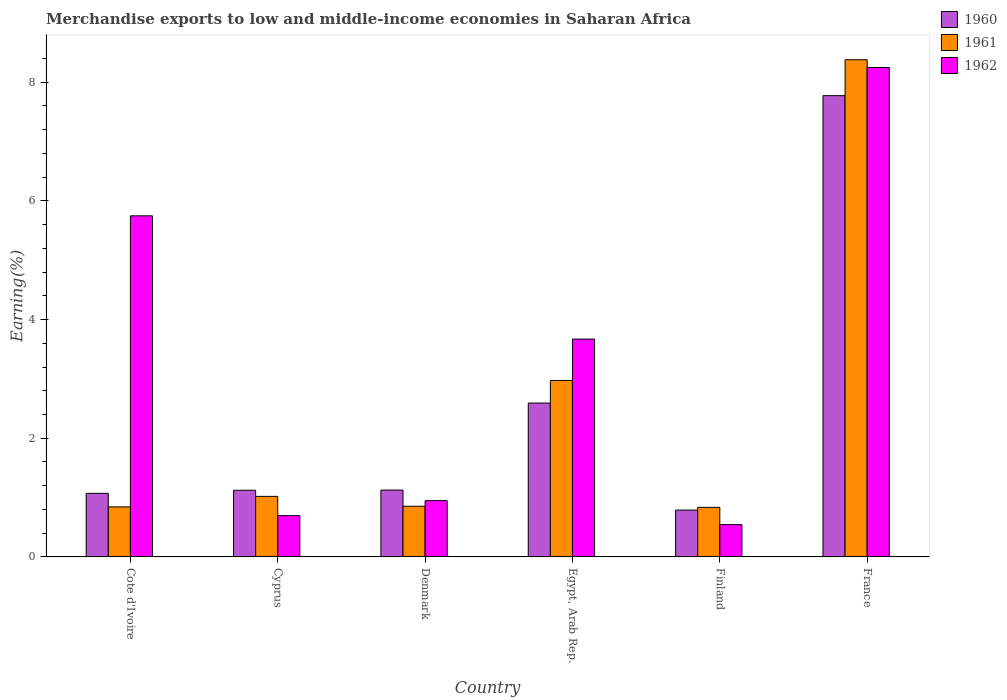Are the number of bars on each tick of the X-axis equal?
Your response must be concise. Yes. How many bars are there on the 3rd tick from the left?
Ensure brevity in your answer.  3. How many bars are there on the 4th tick from the right?
Make the answer very short. 3. What is the label of the 2nd group of bars from the left?
Give a very brief answer. Cyprus. What is the percentage of amount earned from merchandise exports in 1960 in France?
Your answer should be very brief. 7.77. Across all countries, what is the maximum percentage of amount earned from merchandise exports in 1962?
Provide a short and direct response. 8.25. Across all countries, what is the minimum percentage of amount earned from merchandise exports in 1961?
Keep it short and to the point. 0.84. In which country was the percentage of amount earned from merchandise exports in 1962 maximum?
Provide a short and direct response. France. In which country was the percentage of amount earned from merchandise exports in 1960 minimum?
Offer a terse response. Finland. What is the total percentage of amount earned from merchandise exports in 1962 in the graph?
Provide a succinct answer. 19.86. What is the difference between the percentage of amount earned from merchandise exports in 1962 in Denmark and that in France?
Your response must be concise. -7.3. What is the difference between the percentage of amount earned from merchandise exports in 1960 in Denmark and the percentage of amount earned from merchandise exports in 1961 in Cote d'Ivoire?
Provide a short and direct response. 0.28. What is the average percentage of amount earned from merchandise exports in 1960 per country?
Offer a very short reply. 2.41. What is the difference between the percentage of amount earned from merchandise exports of/in 1960 and percentage of amount earned from merchandise exports of/in 1961 in Egypt, Arab Rep.?
Your answer should be very brief. -0.38. What is the ratio of the percentage of amount earned from merchandise exports in 1960 in Egypt, Arab Rep. to that in France?
Ensure brevity in your answer.  0.33. Is the percentage of amount earned from merchandise exports in 1960 in Egypt, Arab Rep. less than that in Finland?
Provide a short and direct response. No. Is the difference between the percentage of amount earned from merchandise exports in 1960 in Cote d'Ivoire and Denmark greater than the difference between the percentage of amount earned from merchandise exports in 1961 in Cote d'Ivoire and Denmark?
Provide a succinct answer. No. What is the difference between the highest and the second highest percentage of amount earned from merchandise exports in 1961?
Ensure brevity in your answer.  7.36. What is the difference between the highest and the lowest percentage of amount earned from merchandise exports in 1961?
Make the answer very short. 7.54. Is the sum of the percentage of amount earned from merchandise exports in 1960 in Cote d'Ivoire and Cyprus greater than the maximum percentage of amount earned from merchandise exports in 1961 across all countries?
Offer a very short reply. No. What does the 1st bar from the right in Finland represents?
Your answer should be compact. 1962. How many countries are there in the graph?
Provide a succinct answer. 6. What is the difference between two consecutive major ticks on the Y-axis?
Keep it short and to the point. 2. Does the graph contain any zero values?
Keep it short and to the point. No. Does the graph contain grids?
Make the answer very short. No. Where does the legend appear in the graph?
Keep it short and to the point. Top right. How many legend labels are there?
Your answer should be compact. 3. How are the legend labels stacked?
Ensure brevity in your answer.  Vertical. What is the title of the graph?
Provide a succinct answer. Merchandise exports to low and middle-income economies in Saharan Africa. Does "1987" appear as one of the legend labels in the graph?
Keep it short and to the point. No. What is the label or title of the X-axis?
Your answer should be compact. Country. What is the label or title of the Y-axis?
Offer a very short reply. Earning(%). What is the Earning(%) of 1960 in Cote d'Ivoire?
Provide a succinct answer. 1.07. What is the Earning(%) in 1961 in Cote d'Ivoire?
Keep it short and to the point. 0.84. What is the Earning(%) in 1962 in Cote d'Ivoire?
Your response must be concise. 5.75. What is the Earning(%) in 1960 in Cyprus?
Offer a terse response. 1.12. What is the Earning(%) in 1961 in Cyprus?
Keep it short and to the point. 1.02. What is the Earning(%) of 1962 in Cyprus?
Your response must be concise. 0.7. What is the Earning(%) in 1960 in Denmark?
Keep it short and to the point. 1.13. What is the Earning(%) of 1961 in Denmark?
Give a very brief answer. 0.85. What is the Earning(%) in 1962 in Denmark?
Ensure brevity in your answer.  0.95. What is the Earning(%) of 1960 in Egypt, Arab Rep.?
Offer a very short reply. 2.59. What is the Earning(%) of 1961 in Egypt, Arab Rep.?
Your answer should be very brief. 2.97. What is the Earning(%) in 1962 in Egypt, Arab Rep.?
Make the answer very short. 3.67. What is the Earning(%) of 1960 in Finland?
Offer a very short reply. 0.79. What is the Earning(%) of 1961 in Finland?
Your response must be concise. 0.84. What is the Earning(%) in 1962 in Finland?
Make the answer very short. 0.54. What is the Earning(%) in 1960 in France?
Your response must be concise. 7.77. What is the Earning(%) in 1961 in France?
Provide a succinct answer. 8.38. What is the Earning(%) of 1962 in France?
Provide a short and direct response. 8.25. Across all countries, what is the maximum Earning(%) of 1960?
Your response must be concise. 7.77. Across all countries, what is the maximum Earning(%) in 1961?
Provide a short and direct response. 8.38. Across all countries, what is the maximum Earning(%) in 1962?
Offer a terse response. 8.25. Across all countries, what is the minimum Earning(%) in 1960?
Offer a very short reply. 0.79. Across all countries, what is the minimum Earning(%) in 1961?
Provide a succinct answer. 0.84. Across all countries, what is the minimum Earning(%) in 1962?
Provide a succinct answer. 0.54. What is the total Earning(%) of 1960 in the graph?
Give a very brief answer. 14.48. What is the total Earning(%) in 1961 in the graph?
Your answer should be compact. 14.91. What is the total Earning(%) of 1962 in the graph?
Give a very brief answer. 19.86. What is the difference between the Earning(%) of 1960 in Cote d'Ivoire and that in Cyprus?
Offer a very short reply. -0.05. What is the difference between the Earning(%) in 1961 in Cote d'Ivoire and that in Cyprus?
Keep it short and to the point. -0.18. What is the difference between the Earning(%) of 1962 in Cote d'Ivoire and that in Cyprus?
Offer a very short reply. 5.05. What is the difference between the Earning(%) in 1960 in Cote d'Ivoire and that in Denmark?
Offer a terse response. -0.06. What is the difference between the Earning(%) of 1961 in Cote d'Ivoire and that in Denmark?
Provide a short and direct response. -0.01. What is the difference between the Earning(%) in 1962 in Cote d'Ivoire and that in Denmark?
Offer a very short reply. 4.8. What is the difference between the Earning(%) of 1960 in Cote d'Ivoire and that in Egypt, Arab Rep.?
Make the answer very short. -1.52. What is the difference between the Earning(%) of 1961 in Cote d'Ivoire and that in Egypt, Arab Rep.?
Your answer should be compact. -2.13. What is the difference between the Earning(%) in 1962 in Cote d'Ivoire and that in Egypt, Arab Rep.?
Ensure brevity in your answer.  2.08. What is the difference between the Earning(%) in 1960 in Cote d'Ivoire and that in Finland?
Offer a very short reply. 0.28. What is the difference between the Earning(%) of 1961 in Cote d'Ivoire and that in Finland?
Your answer should be compact. 0.01. What is the difference between the Earning(%) of 1962 in Cote d'Ivoire and that in Finland?
Provide a succinct answer. 5.2. What is the difference between the Earning(%) in 1960 in Cote d'Ivoire and that in France?
Provide a short and direct response. -6.7. What is the difference between the Earning(%) of 1961 in Cote d'Ivoire and that in France?
Offer a very short reply. -7.54. What is the difference between the Earning(%) of 1962 in Cote d'Ivoire and that in France?
Provide a succinct answer. -2.5. What is the difference between the Earning(%) of 1960 in Cyprus and that in Denmark?
Offer a very short reply. -0. What is the difference between the Earning(%) in 1961 in Cyprus and that in Denmark?
Ensure brevity in your answer.  0.17. What is the difference between the Earning(%) in 1962 in Cyprus and that in Denmark?
Give a very brief answer. -0.25. What is the difference between the Earning(%) of 1960 in Cyprus and that in Egypt, Arab Rep.?
Your response must be concise. -1.47. What is the difference between the Earning(%) in 1961 in Cyprus and that in Egypt, Arab Rep.?
Your response must be concise. -1.95. What is the difference between the Earning(%) of 1962 in Cyprus and that in Egypt, Arab Rep.?
Provide a short and direct response. -2.98. What is the difference between the Earning(%) of 1960 in Cyprus and that in Finland?
Provide a succinct answer. 0.33. What is the difference between the Earning(%) of 1961 in Cyprus and that in Finland?
Give a very brief answer. 0.18. What is the difference between the Earning(%) in 1962 in Cyprus and that in Finland?
Keep it short and to the point. 0.15. What is the difference between the Earning(%) in 1960 in Cyprus and that in France?
Your answer should be compact. -6.65. What is the difference between the Earning(%) in 1961 in Cyprus and that in France?
Give a very brief answer. -7.36. What is the difference between the Earning(%) of 1962 in Cyprus and that in France?
Your answer should be very brief. -7.55. What is the difference between the Earning(%) in 1960 in Denmark and that in Egypt, Arab Rep.?
Provide a short and direct response. -1.47. What is the difference between the Earning(%) of 1961 in Denmark and that in Egypt, Arab Rep.?
Offer a very short reply. -2.12. What is the difference between the Earning(%) of 1962 in Denmark and that in Egypt, Arab Rep.?
Ensure brevity in your answer.  -2.72. What is the difference between the Earning(%) in 1960 in Denmark and that in Finland?
Keep it short and to the point. 0.34. What is the difference between the Earning(%) in 1961 in Denmark and that in Finland?
Offer a very short reply. 0.02. What is the difference between the Earning(%) of 1962 in Denmark and that in Finland?
Provide a short and direct response. 0.4. What is the difference between the Earning(%) of 1960 in Denmark and that in France?
Your answer should be very brief. -6.65. What is the difference between the Earning(%) in 1961 in Denmark and that in France?
Your response must be concise. -7.53. What is the difference between the Earning(%) in 1962 in Denmark and that in France?
Your answer should be compact. -7.3. What is the difference between the Earning(%) in 1960 in Egypt, Arab Rep. and that in Finland?
Ensure brevity in your answer.  1.8. What is the difference between the Earning(%) of 1961 in Egypt, Arab Rep. and that in Finland?
Your response must be concise. 2.14. What is the difference between the Earning(%) in 1962 in Egypt, Arab Rep. and that in Finland?
Your answer should be compact. 3.13. What is the difference between the Earning(%) in 1960 in Egypt, Arab Rep. and that in France?
Offer a terse response. -5.18. What is the difference between the Earning(%) in 1961 in Egypt, Arab Rep. and that in France?
Make the answer very short. -5.41. What is the difference between the Earning(%) of 1962 in Egypt, Arab Rep. and that in France?
Your response must be concise. -4.58. What is the difference between the Earning(%) in 1960 in Finland and that in France?
Keep it short and to the point. -6.98. What is the difference between the Earning(%) of 1961 in Finland and that in France?
Ensure brevity in your answer.  -7.54. What is the difference between the Earning(%) of 1962 in Finland and that in France?
Your answer should be compact. -7.7. What is the difference between the Earning(%) in 1960 in Cote d'Ivoire and the Earning(%) in 1961 in Cyprus?
Give a very brief answer. 0.05. What is the difference between the Earning(%) in 1960 in Cote d'Ivoire and the Earning(%) in 1962 in Cyprus?
Offer a very short reply. 0.38. What is the difference between the Earning(%) in 1961 in Cote d'Ivoire and the Earning(%) in 1962 in Cyprus?
Ensure brevity in your answer.  0.15. What is the difference between the Earning(%) in 1960 in Cote d'Ivoire and the Earning(%) in 1961 in Denmark?
Offer a very short reply. 0.22. What is the difference between the Earning(%) in 1960 in Cote d'Ivoire and the Earning(%) in 1962 in Denmark?
Your response must be concise. 0.12. What is the difference between the Earning(%) in 1961 in Cote d'Ivoire and the Earning(%) in 1962 in Denmark?
Provide a short and direct response. -0.11. What is the difference between the Earning(%) in 1960 in Cote d'Ivoire and the Earning(%) in 1961 in Egypt, Arab Rep.?
Provide a short and direct response. -1.9. What is the difference between the Earning(%) of 1960 in Cote d'Ivoire and the Earning(%) of 1962 in Egypt, Arab Rep.?
Provide a succinct answer. -2.6. What is the difference between the Earning(%) in 1961 in Cote d'Ivoire and the Earning(%) in 1962 in Egypt, Arab Rep.?
Your answer should be compact. -2.83. What is the difference between the Earning(%) in 1960 in Cote d'Ivoire and the Earning(%) in 1961 in Finland?
Offer a terse response. 0.24. What is the difference between the Earning(%) of 1960 in Cote d'Ivoire and the Earning(%) of 1962 in Finland?
Provide a succinct answer. 0.53. What is the difference between the Earning(%) in 1961 in Cote d'Ivoire and the Earning(%) in 1962 in Finland?
Ensure brevity in your answer.  0.3. What is the difference between the Earning(%) in 1960 in Cote d'Ivoire and the Earning(%) in 1961 in France?
Make the answer very short. -7.31. What is the difference between the Earning(%) in 1960 in Cote d'Ivoire and the Earning(%) in 1962 in France?
Offer a terse response. -7.18. What is the difference between the Earning(%) in 1961 in Cote d'Ivoire and the Earning(%) in 1962 in France?
Provide a succinct answer. -7.41. What is the difference between the Earning(%) of 1960 in Cyprus and the Earning(%) of 1961 in Denmark?
Give a very brief answer. 0.27. What is the difference between the Earning(%) in 1960 in Cyprus and the Earning(%) in 1962 in Denmark?
Offer a terse response. 0.18. What is the difference between the Earning(%) of 1961 in Cyprus and the Earning(%) of 1962 in Denmark?
Offer a terse response. 0.07. What is the difference between the Earning(%) of 1960 in Cyprus and the Earning(%) of 1961 in Egypt, Arab Rep.?
Give a very brief answer. -1.85. What is the difference between the Earning(%) in 1960 in Cyprus and the Earning(%) in 1962 in Egypt, Arab Rep.?
Your answer should be compact. -2.55. What is the difference between the Earning(%) in 1961 in Cyprus and the Earning(%) in 1962 in Egypt, Arab Rep.?
Give a very brief answer. -2.65. What is the difference between the Earning(%) in 1960 in Cyprus and the Earning(%) in 1961 in Finland?
Make the answer very short. 0.29. What is the difference between the Earning(%) of 1960 in Cyprus and the Earning(%) of 1962 in Finland?
Provide a short and direct response. 0.58. What is the difference between the Earning(%) in 1961 in Cyprus and the Earning(%) in 1962 in Finland?
Keep it short and to the point. 0.48. What is the difference between the Earning(%) in 1960 in Cyprus and the Earning(%) in 1961 in France?
Provide a short and direct response. -7.26. What is the difference between the Earning(%) of 1960 in Cyprus and the Earning(%) of 1962 in France?
Provide a short and direct response. -7.13. What is the difference between the Earning(%) in 1961 in Cyprus and the Earning(%) in 1962 in France?
Your answer should be compact. -7.23. What is the difference between the Earning(%) of 1960 in Denmark and the Earning(%) of 1961 in Egypt, Arab Rep.?
Your response must be concise. -1.85. What is the difference between the Earning(%) in 1960 in Denmark and the Earning(%) in 1962 in Egypt, Arab Rep.?
Your response must be concise. -2.54. What is the difference between the Earning(%) of 1961 in Denmark and the Earning(%) of 1962 in Egypt, Arab Rep.?
Provide a succinct answer. -2.82. What is the difference between the Earning(%) of 1960 in Denmark and the Earning(%) of 1961 in Finland?
Your response must be concise. 0.29. What is the difference between the Earning(%) in 1960 in Denmark and the Earning(%) in 1962 in Finland?
Your answer should be very brief. 0.58. What is the difference between the Earning(%) in 1961 in Denmark and the Earning(%) in 1962 in Finland?
Offer a terse response. 0.31. What is the difference between the Earning(%) in 1960 in Denmark and the Earning(%) in 1961 in France?
Your response must be concise. -7.25. What is the difference between the Earning(%) of 1960 in Denmark and the Earning(%) of 1962 in France?
Ensure brevity in your answer.  -7.12. What is the difference between the Earning(%) in 1961 in Denmark and the Earning(%) in 1962 in France?
Make the answer very short. -7.39. What is the difference between the Earning(%) in 1960 in Egypt, Arab Rep. and the Earning(%) in 1961 in Finland?
Keep it short and to the point. 1.76. What is the difference between the Earning(%) in 1960 in Egypt, Arab Rep. and the Earning(%) in 1962 in Finland?
Provide a succinct answer. 2.05. What is the difference between the Earning(%) in 1961 in Egypt, Arab Rep. and the Earning(%) in 1962 in Finland?
Ensure brevity in your answer.  2.43. What is the difference between the Earning(%) of 1960 in Egypt, Arab Rep. and the Earning(%) of 1961 in France?
Provide a succinct answer. -5.79. What is the difference between the Earning(%) in 1960 in Egypt, Arab Rep. and the Earning(%) in 1962 in France?
Offer a very short reply. -5.66. What is the difference between the Earning(%) in 1961 in Egypt, Arab Rep. and the Earning(%) in 1962 in France?
Give a very brief answer. -5.28. What is the difference between the Earning(%) of 1960 in Finland and the Earning(%) of 1961 in France?
Keep it short and to the point. -7.59. What is the difference between the Earning(%) of 1960 in Finland and the Earning(%) of 1962 in France?
Give a very brief answer. -7.46. What is the difference between the Earning(%) in 1961 in Finland and the Earning(%) in 1962 in France?
Offer a terse response. -7.41. What is the average Earning(%) in 1960 per country?
Keep it short and to the point. 2.41. What is the average Earning(%) in 1961 per country?
Keep it short and to the point. 2.48. What is the average Earning(%) of 1962 per country?
Keep it short and to the point. 3.31. What is the difference between the Earning(%) in 1960 and Earning(%) in 1961 in Cote d'Ivoire?
Offer a terse response. 0.23. What is the difference between the Earning(%) in 1960 and Earning(%) in 1962 in Cote d'Ivoire?
Offer a terse response. -4.68. What is the difference between the Earning(%) in 1961 and Earning(%) in 1962 in Cote d'Ivoire?
Offer a terse response. -4.91. What is the difference between the Earning(%) in 1960 and Earning(%) in 1961 in Cyprus?
Provide a short and direct response. 0.1. What is the difference between the Earning(%) of 1960 and Earning(%) of 1962 in Cyprus?
Your answer should be very brief. 0.43. What is the difference between the Earning(%) in 1961 and Earning(%) in 1962 in Cyprus?
Give a very brief answer. 0.32. What is the difference between the Earning(%) in 1960 and Earning(%) in 1961 in Denmark?
Your answer should be compact. 0.27. What is the difference between the Earning(%) in 1960 and Earning(%) in 1962 in Denmark?
Provide a succinct answer. 0.18. What is the difference between the Earning(%) in 1961 and Earning(%) in 1962 in Denmark?
Keep it short and to the point. -0.09. What is the difference between the Earning(%) of 1960 and Earning(%) of 1961 in Egypt, Arab Rep.?
Keep it short and to the point. -0.38. What is the difference between the Earning(%) of 1960 and Earning(%) of 1962 in Egypt, Arab Rep.?
Your answer should be compact. -1.08. What is the difference between the Earning(%) of 1961 and Earning(%) of 1962 in Egypt, Arab Rep.?
Make the answer very short. -0.7. What is the difference between the Earning(%) in 1960 and Earning(%) in 1961 in Finland?
Your answer should be very brief. -0.05. What is the difference between the Earning(%) in 1960 and Earning(%) in 1962 in Finland?
Your answer should be compact. 0.25. What is the difference between the Earning(%) in 1961 and Earning(%) in 1962 in Finland?
Your response must be concise. 0.29. What is the difference between the Earning(%) of 1960 and Earning(%) of 1961 in France?
Offer a terse response. -0.61. What is the difference between the Earning(%) of 1960 and Earning(%) of 1962 in France?
Your response must be concise. -0.47. What is the difference between the Earning(%) in 1961 and Earning(%) in 1962 in France?
Give a very brief answer. 0.13. What is the ratio of the Earning(%) of 1960 in Cote d'Ivoire to that in Cyprus?
Your response must be concise. 0.95. What is the ratio of the Earning(%) in 1961 in Cote d'Ivoire to that in Cyprus?
Your response must be concise. 0.83. What is the ratio of the Earning(%) in 1962 in Cote d'Ivoire to that in Cyprus?
Offer a very short reply. 8.26. What is the ratio of the Earning(%) in 1960 in Cote d'Ivoire to that in Denmark?
Give a very brief answer. 0.95. What is the ratio of the Earning(%) of 1962 in Cote d'Ivoire to that in Denmark?
Provide a succinct answer. 6.06. What is the ratio of the Earning(%) of 1960 in Cote d'Ivoire to that in Egypt, Arab Rep.?
Provide a short and direct response. 0.41. What is the ratio of the Earning(%) of 1961 in Cote d'Ivoire to that in Egypt, Arab Rep.?
Provide a succinct answer. 0.28. What is the ratio of the Earning(%) of 1962 in Cote d'Ivoire to that in Egypt, Arab Rep.?
Provide a short and direct response. 1.57. What is the ratio of the Earning(%) in 1960 in Cote d'Ivoire to that in Finland?
Your response must be concise. 1.36. What is the ratio of the Earning(%) in 1961 in Cote d'Ivoire to that in Finland?
Provide a short and direct response. 1.01. What is the ratio of the Earning(%) in 1962 in Cote d'Ivoire to that in Finland?
Provide a succinct answer. 10.57. What is the ratio of the Earning(%) of 1960 in Cote d'Ivoire to that in France?
Make the answer very short. 0.14. What is the ratio of the Earning(%) of 1961 in Cote d'Ivoire to that in France?
Ensure brevity in your answer.  0.1. What is the ratio of the Earning(%) in 1962 in Cote d'Ivoire to that in France?
Offer a very short reply. 0.7. What is the ratio of the Earning(%) of 1960 in Cyprus to that in Denmark?
Your answer should be compact. 1. What is the ratio of the Earning(%) of 1961 in Cyprus to that in Denmark?
Your response must be concise. 1.2. What is the ratio of the Earning(%) of 1962 in Cyprus to that in Denmark?
Your response must be concise. 0.73. What is the ratio of the Earning(%) in 1960 in Cyprus to that in Egypt, Arab Rep.?
Provide a short and direct response. 0.43. What is the ratio of the Earning(%) in 1961 in Cyprus to that in Egypt, Arab Rep.?
Provide a short and direct response. 0.34. What is the ratio of the Earning(%) of 1962 in Cyprus to that in Egypt, Arab Rep.?
Offer a terse response. 0.19. What is the ratio of the Earning(%) of 1960 in Cyprus to that in Finland?
Your response must be concise. 1.42. What is the ratio of the Earning(%) of 1961 in Cyprus to that in Finland?
Your answer should be very brief. 1.22. What is the ratio of the Earning(%) in 1962 in Cyprus to that in Finland?
Give a very brief answer. 1.28. What is the ratio of the Earning(%) of 1960 in Cyprus to that in France?
Make the answer very short. 0.14. What is the ratio of the Earning(%) of 1961 in Cyprus to that in France?
Ensure brevity in your answer.  0.12. What is the ratio of the Earning(%) in 1962 in Cyprus to that in France?
Give a very brief answer. 0.08. What is the ratio of the Earning(%) in 1960 in Denmark to that in Egypt, Arab Rep.?
Provide a short and direct response. 0.43. What is the ratio of the Earning(%) of 1961 in Denmark to that in Egypt, Arab Rep.?
Provide a succinct answer. 0.29. What is the ratio of the Earning(%) of 1962 in Denmark to that in Egypt, Arab Rep.?
Make the answer very short. 0.26. What is the ratio of the Earning(%) in 1960 in Denmark to that in Finland?
Give a very brief answer. 1.43. What is the ratio of the Earning(%) in 1961 in Denmark to that in Finland?
Provide a succinct answer. 1.02. What is the ratio of the Earning(%) in 1962 in Denmark to that in Finland?
Your response must be concise. 1.74. What is the ratio of the Earning(%) of 1960 in Denmark to that in France?
Ensure brevity in your answer.  0.14. What is the ratio of the Earning(%) in 1961 in Denmark to that in France?
Keep it short and to the point. 0.1. What is the ratio of the Earning(%) of 1962 in Denmark to that in France?
Your answer should be very brief. 0.12. What is the ratio of the Earning(%) in 1960 in Egypt, Arab Rep. to that in Finland?
Keep it short and to the point. 3.29. What is the ratio of the Earning(%) of 1961 in Egypt, Arab Rep. to that in Finland?
Provide a short and direct response. 3.56. What is the ratio of the Earning(%) of 1962 in Egypt, Arab Rep. to that in Finland?
Provide a succinct answer. 6.75. What is the ratio of the Earning(%) in 1960 in Egypt, Arab Rep. to that in France?
Keep it short and to the point. 0.33. What is the ratio of the Earning(%) of 1961 in Egypt, Arab Rep. to that in France?
Keep it short and to the point. 0.35. What is the ratio of the Earning(%) of 1962 in Egypt, Arab Rep. to that in France?
Give a very brief answer. 0.45. What is the ratio of the Earning(%) in 1960 in Finland to that in France?
Offer a terse response. 0.1. What is the ratio of the Earning(%) in 1961 in Finland to that in France?
Keep it short and to the point. 0.1. What is the ratio of the Earning(%) in 1962 in Finland to that in France?
Give a very brief answer. 0.07. What is the difference between the highest and the second highest Earning(%) in 1960?
Ensure brevity in your answer.  5.18. What is the difference between the highest and the second highest Earning(%) in 1961?
Provide a short and direct response. 5.41. What is the difference between the highest and the second highest Earning(%) of 1962?
Your answer should be very brief. 2.5. What is the difference between the highest and the lowest Earning(%) of 1960?
Give a very brief answer. 6.98. What is the difference between the highest and the lowest Earning(%) of 1961?
Keep it short and to the point. 7.54. What is the difference between the highest and the lowest Earning(%) of 1962?
Your answer should be very brief. 7.7. 